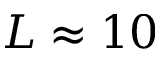<formula> <loc_0><loc_0><loc_500><loc_500>L \approx 1 0</formula> 